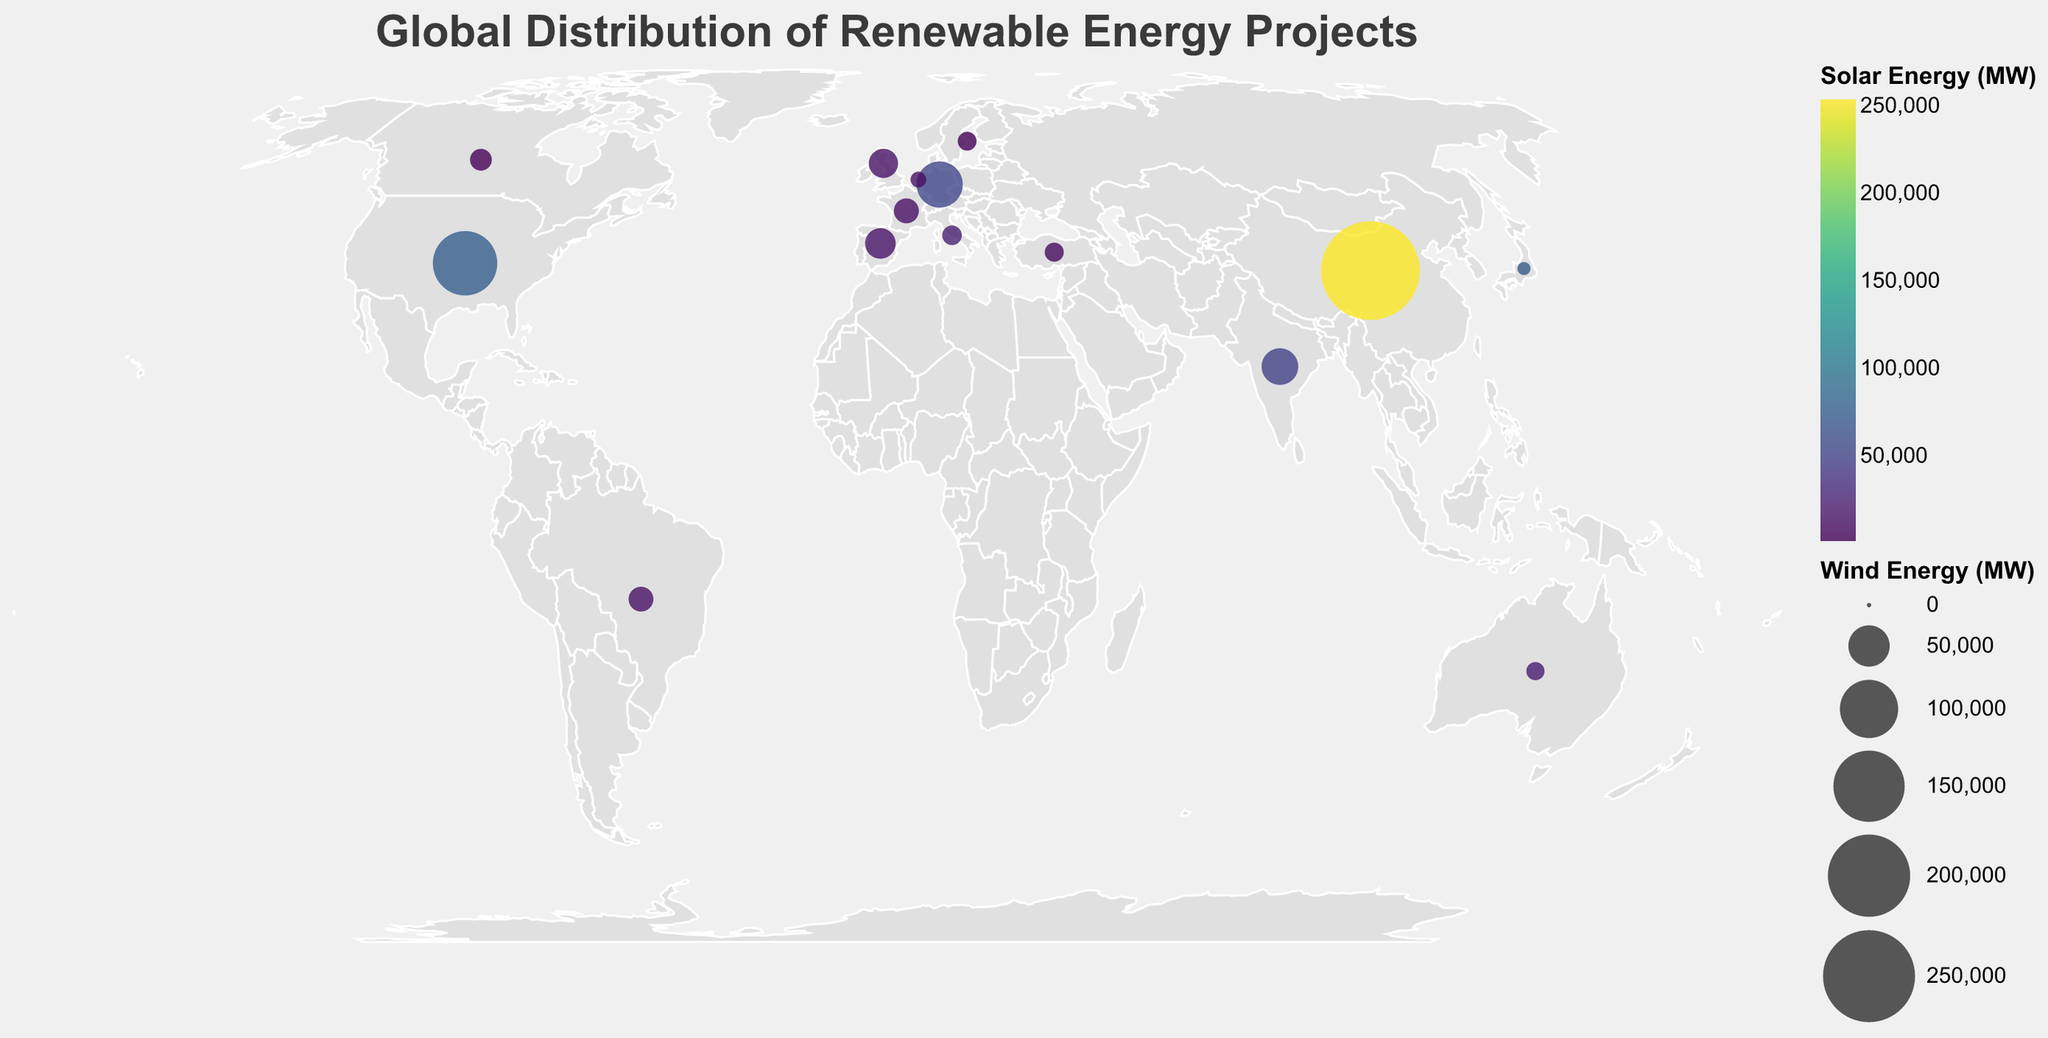How many countries are represented in the plot? Count the number of unique country names present in the data set displayed on the plot.
Answer: 14 Which country has the highest wind energy capacity? Identify the country with the largest circle size, as the circle size represents wind energy capacity (MW).
Answer: China What does the color of the circles represent on the plot? Refer to the color legend provided in the plot, which indicates what attribute the colors correspond to.
Answer: Solar Energy (MW) Which two countries have similar solar energy capacities but differ significantly in wind energy capacities? Look for two countries where the circle colors are similar but their sizes differ notably, as this indicates similar solar but different wind energy capacities. India and Spain fit this description.
Answer: India and Spain Which country has the lowest hydroelectric energy capacity? Check the tooltip data for all countries to find the one with the smallest value for hydro energy (MW). The Netherlands has the smallest hydro capacity.
Answer: Netherlands How does the hydroelectric energy capacity in Canada compare to that in Brazil? Compare the hydro energy (MW) values for both Canada and Brazil using the tooltip information. Canada's hydro capacity (81,386 MW) is lower than Brazil's (109,271 MW).
Answer: Lower Is there a country with a higher solar energy capacity than wind energy capacity? If yes, name one such country. Check for each country if Solar_MW > Wind_MW based on tooltip values. Japan, for instance, has a higher solar energy capacity (71,990 MW) compared to its wind energy capacity (4,470 MW).
Answer: Japan Which country has the highest total renewable energy capacity (sum of wind, solar, and hydro)? Sum the wind, solar, and hydro capacities for each country and compare. China has the highest total renewable energy capacity (288,320 + 253,800 + 356,400 = 898,520 MW).
Answer: China What geographic region shows a high density of renewable energy projects? Observe the plot for regions with many large and brightly colored circles. Asia, particularly China and India, shows a high density of renewable energy projects.
Answer: Asia Which country in Europe has the highest wind energy capacity? Identify the country in Europe with the largest circle size representing wind energy capacity. Germany has the highest wind energy capacity in Europe.
Answer: Germany 